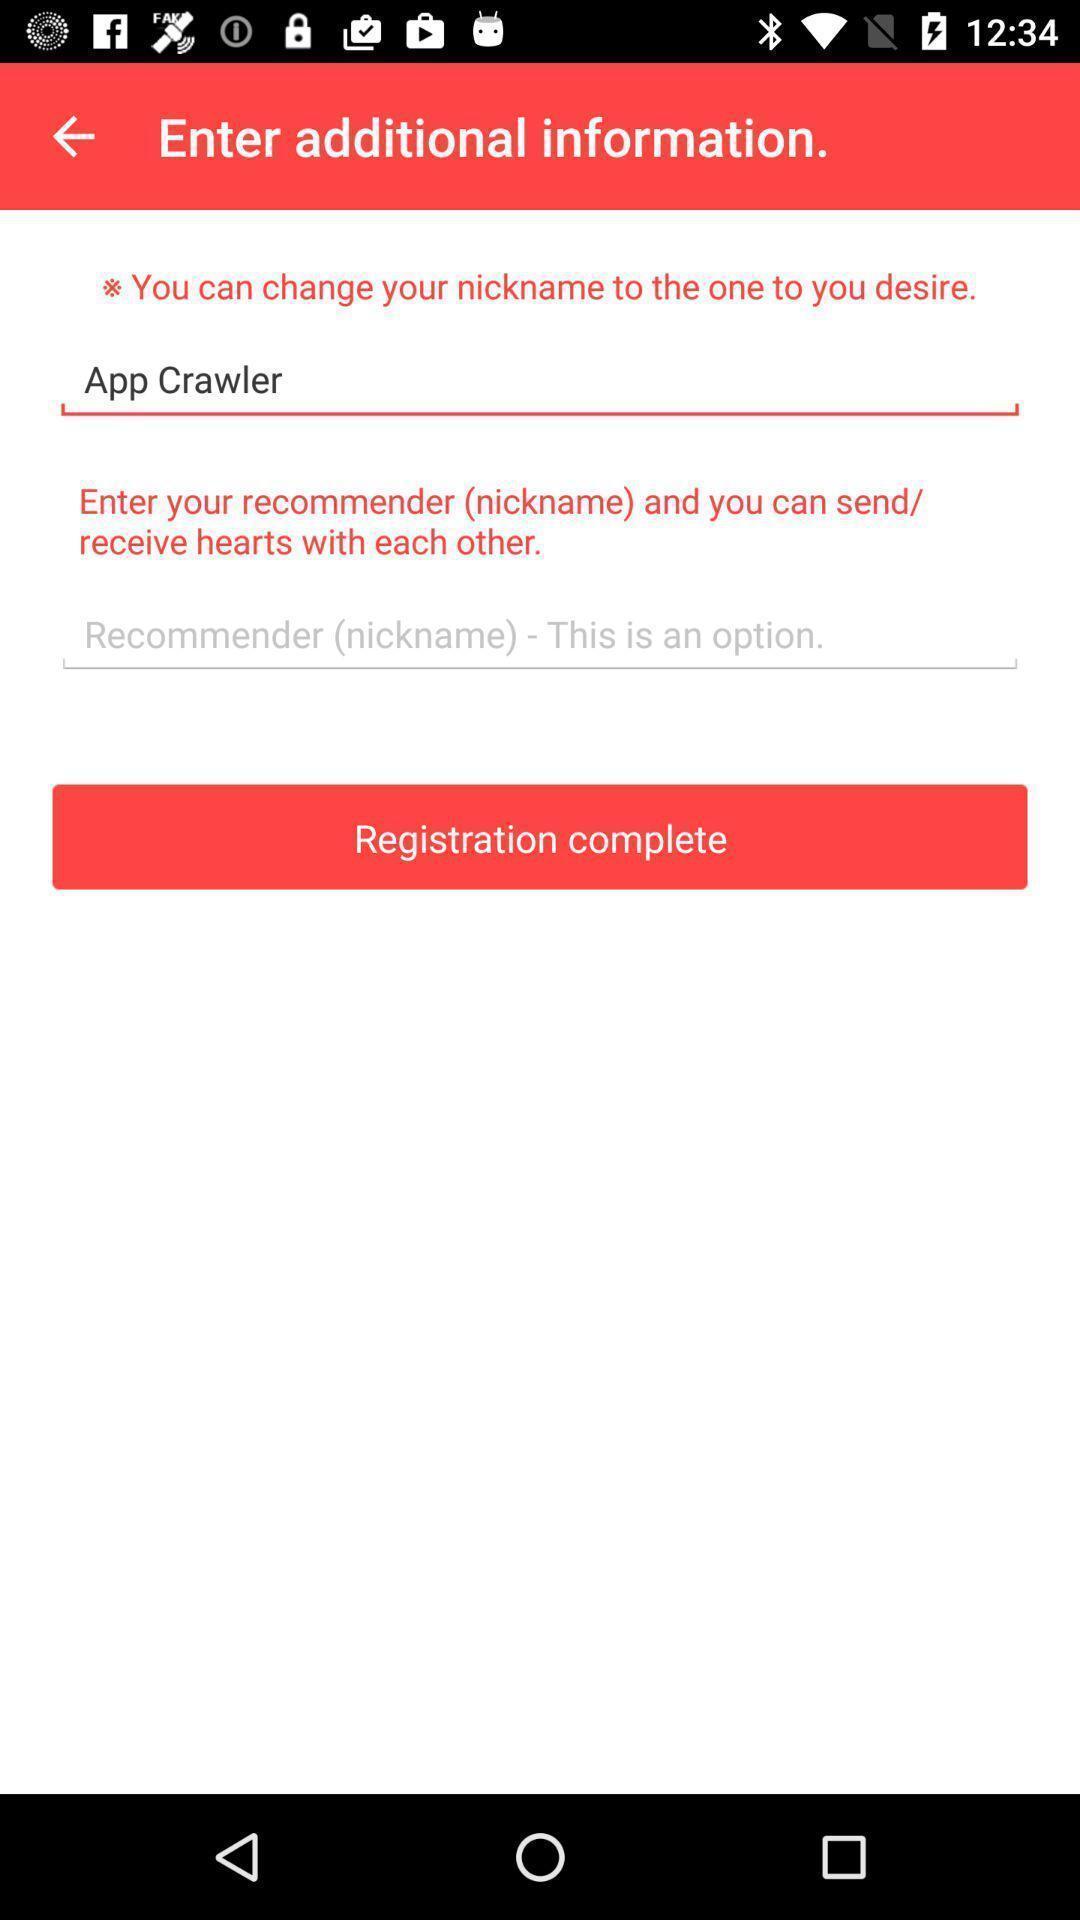Give me a narrative description of this picture. Page to enter additional information to register in the app. 